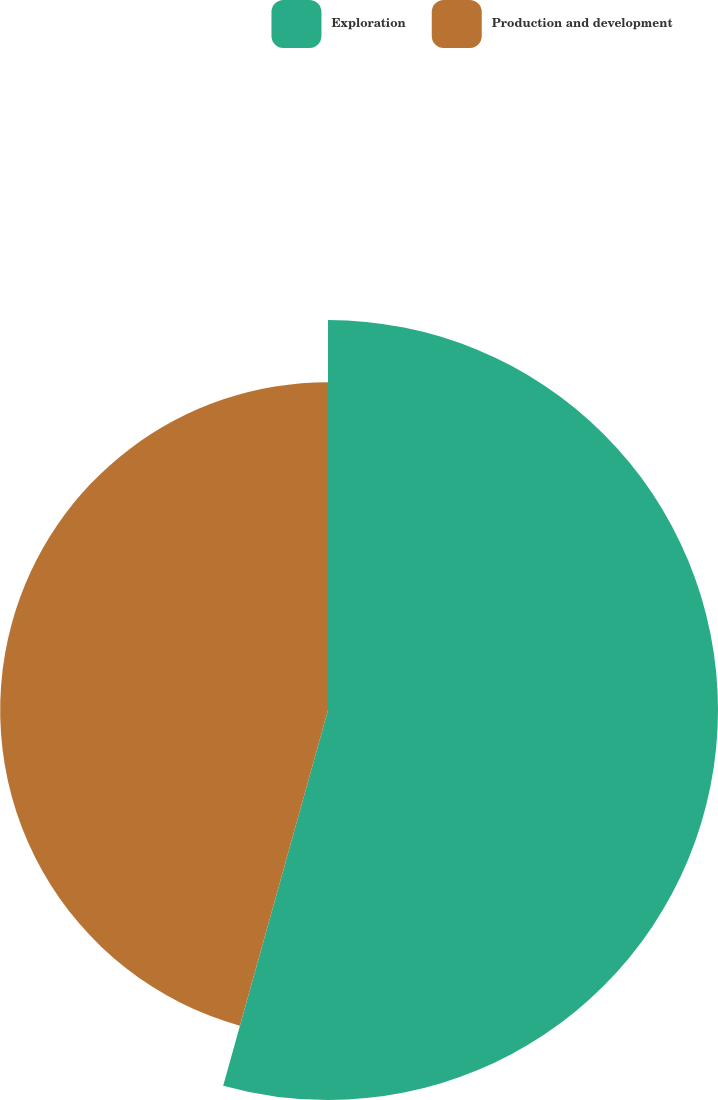Convert chart. <chart><loc_0><loc_0><loc_500><loc_500><pie_chart><fcel>Exploration<fcel>Production and development<nl><fcel>54.33%<fcel>45.67%<nl></chart> 